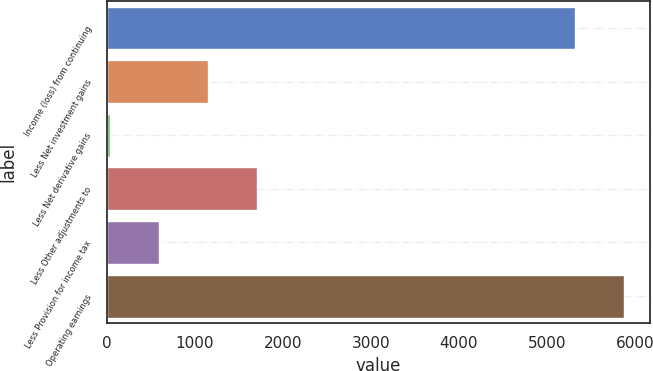<chart> <loc_0><loc_0><loc_500><loc_500><bar_chart><fcel>Income (loss) from continuing<fcel>Less Net investment gains<fcel>Less Net derivative gains<fcel>Less Other adjustments to<fcel>Less Provision for income tax<fcel>Operating earnings<nl><fcel>5322<fcel>1150.4<fcel>38<fcel>1706.6<fcel>594.2<fcel>5878.2<nl></chart> 